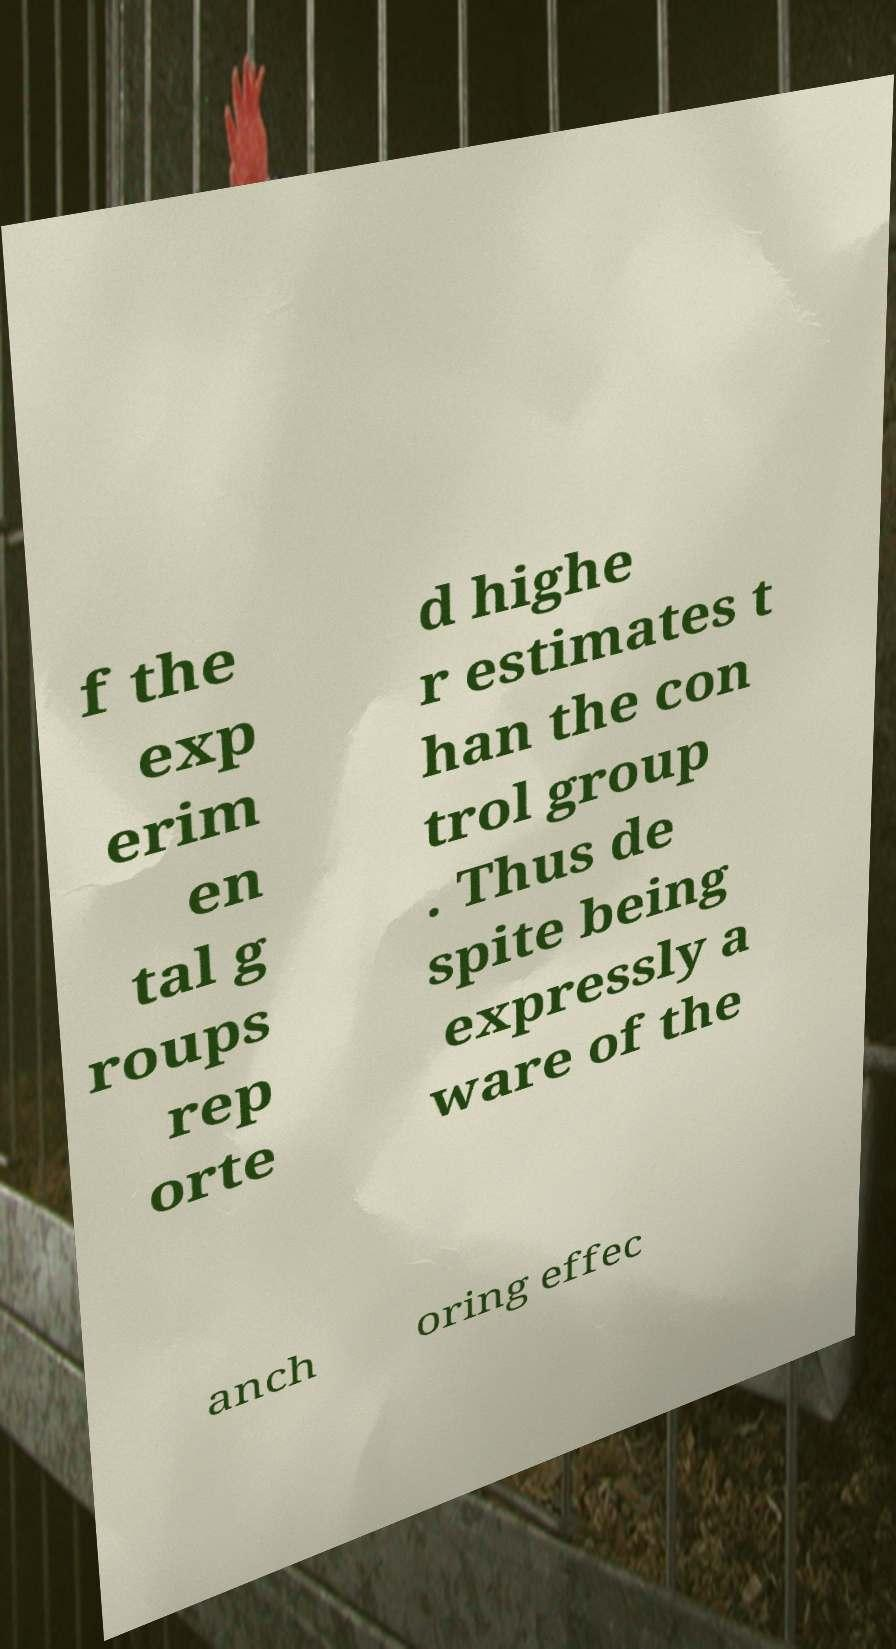What messages or text are displayed in this image? I need them in a readable, typed format. f the exp erim en tal g roups rep orte d highe r estimates t han the con trol group . Thus de spite being expressly a ware of the anch oring effec 